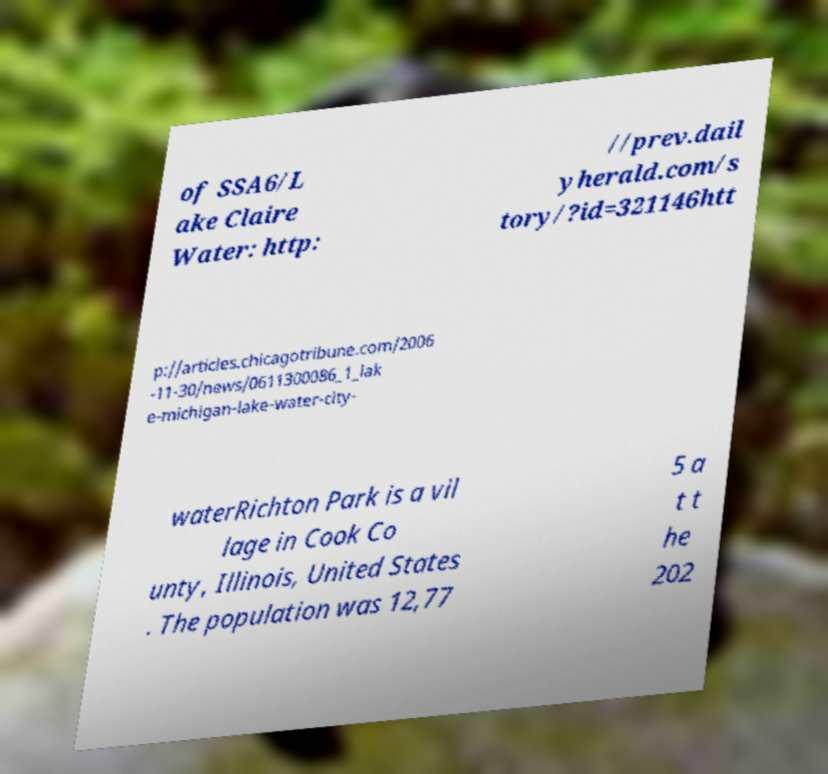Can you accurately transcribe the text from the provided image for me? of SSA6/L ake Claire Water: http: //prev.dail yherald.com/s tory/?id=321146htt p://articles.chicagotribune.com/2006 -11-30/news/0611300086_1_lak e-michigan-lake-water-city- waterRichton Park is a vil lage in Cook Co unty, Illinois, United States . The population was 12,77 5 a t t he 202 